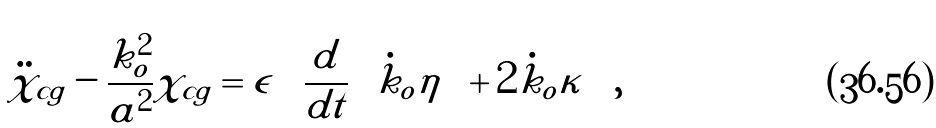<formula> <loc_0><loc_0><loc_500><loc_500>\ddot { \chi } _ { c g } - \frac { k ^ { 2 } _ { o } } { a ^ { 2 } } \chi _ { c g } = \epsilon \left ( \frac { d } { d t } \left ( \dot { k } _ { o } \eta \right ) + 2 \dot { k } _ { o } \kappa \right ) ,</formula> 